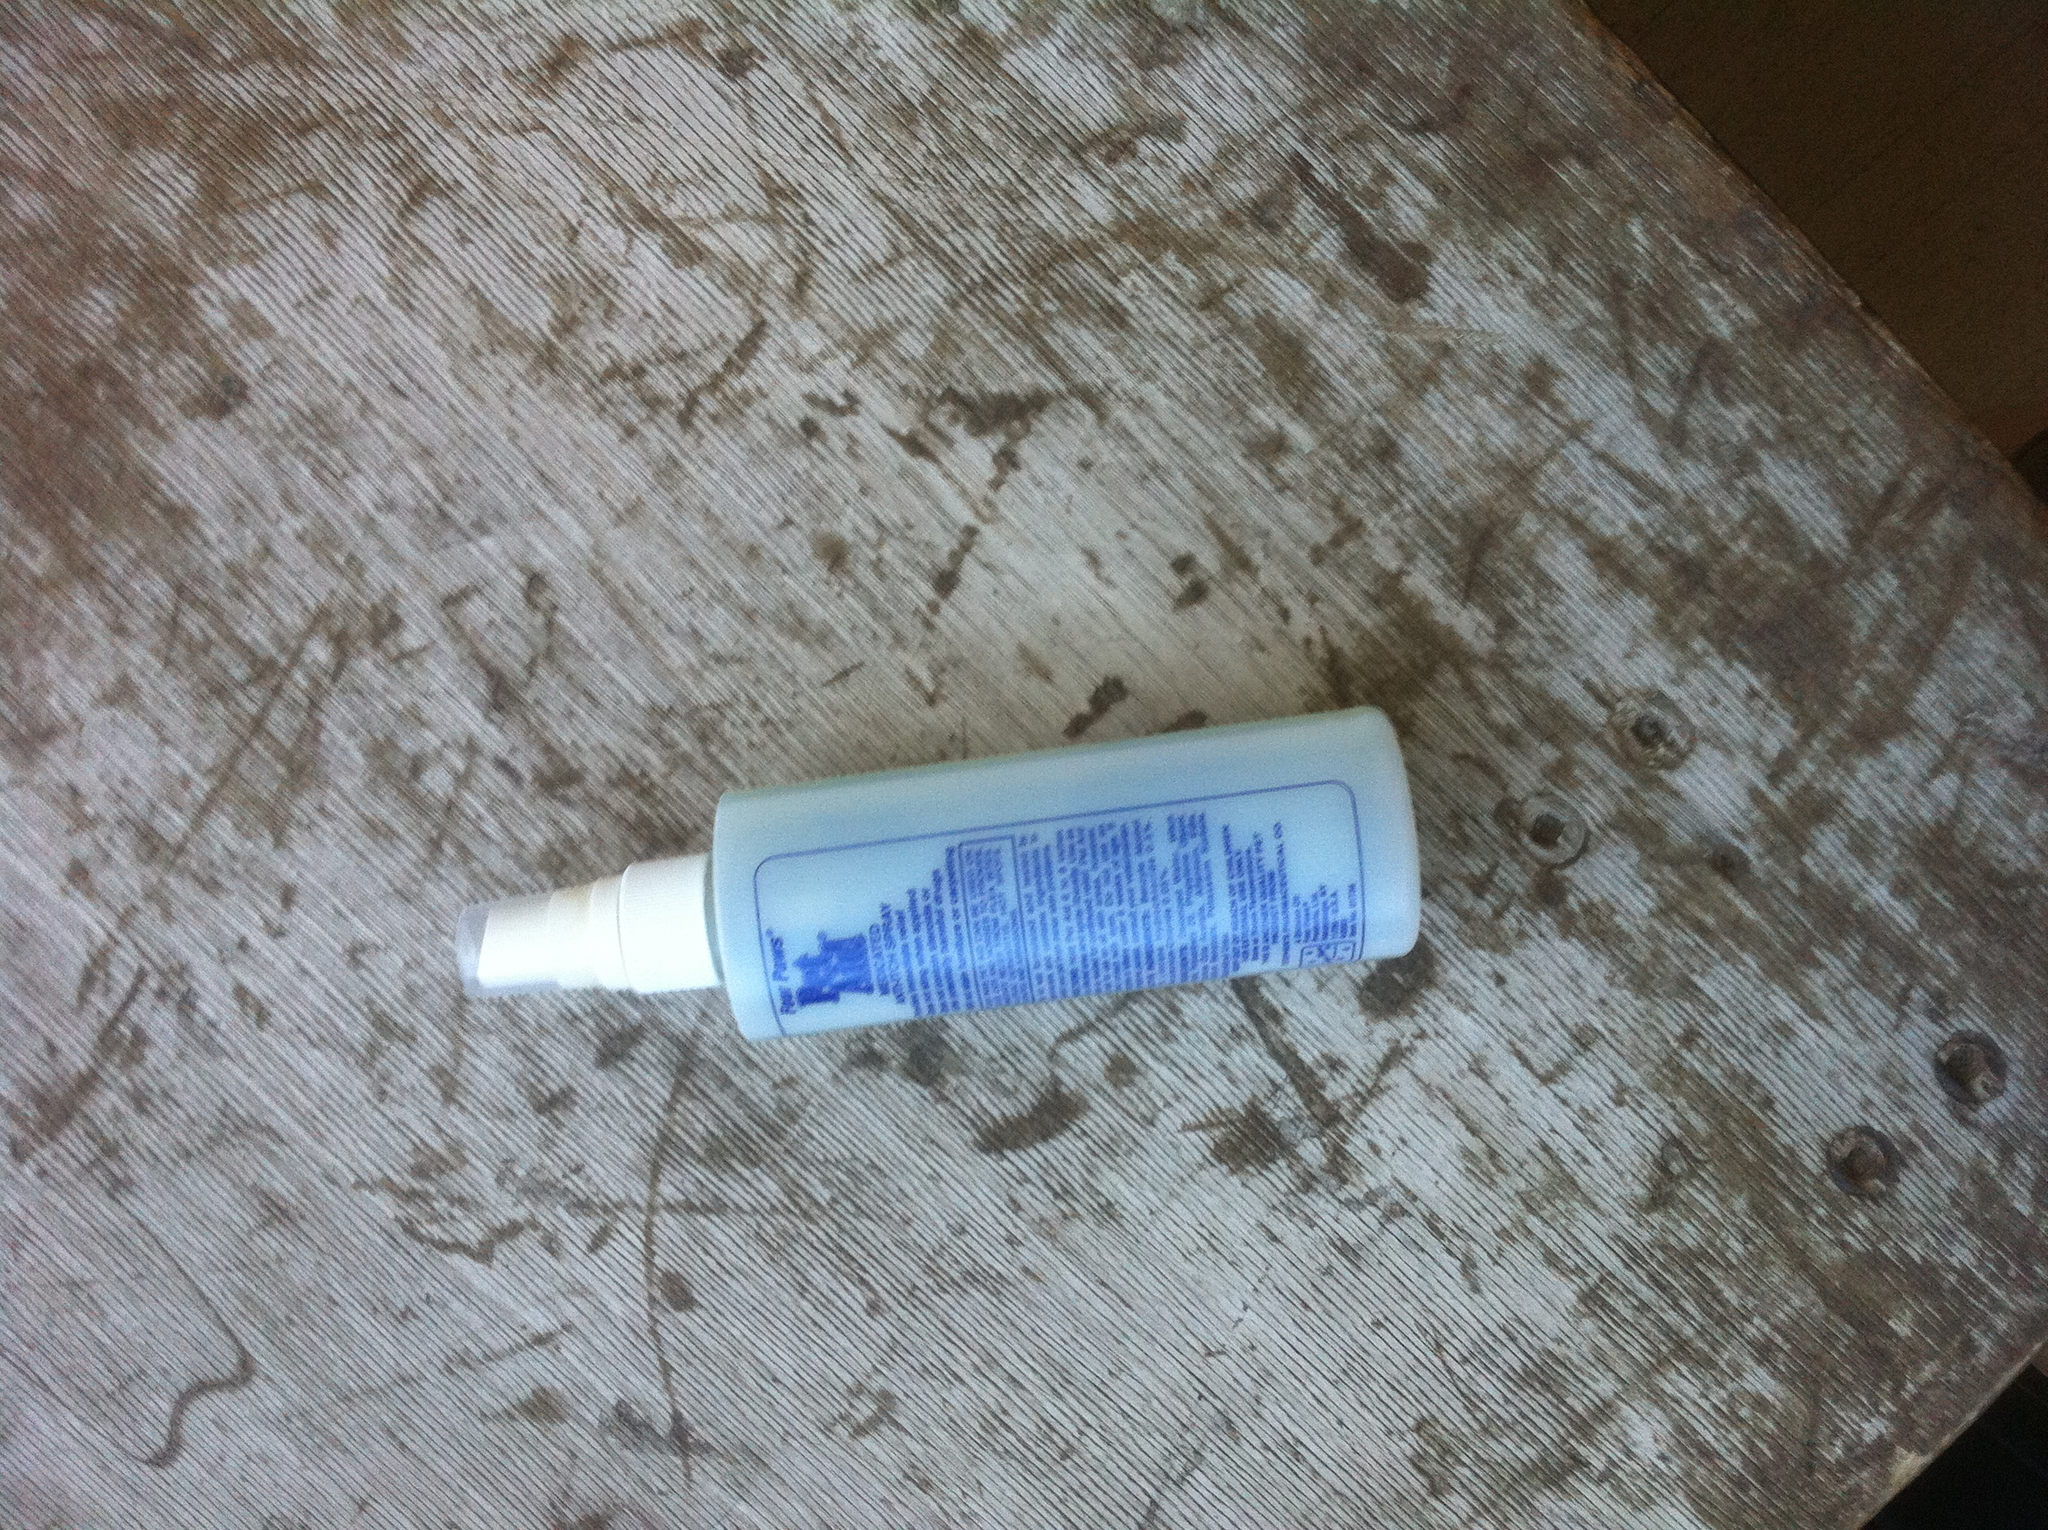What are the possible uses of the product shown in the image? Based on the label, the product is likely a skincare or haircare spray. It may be used for moisturizing, setting makeup, or possibly as a hair treatment to add shine or reduce frizz. 